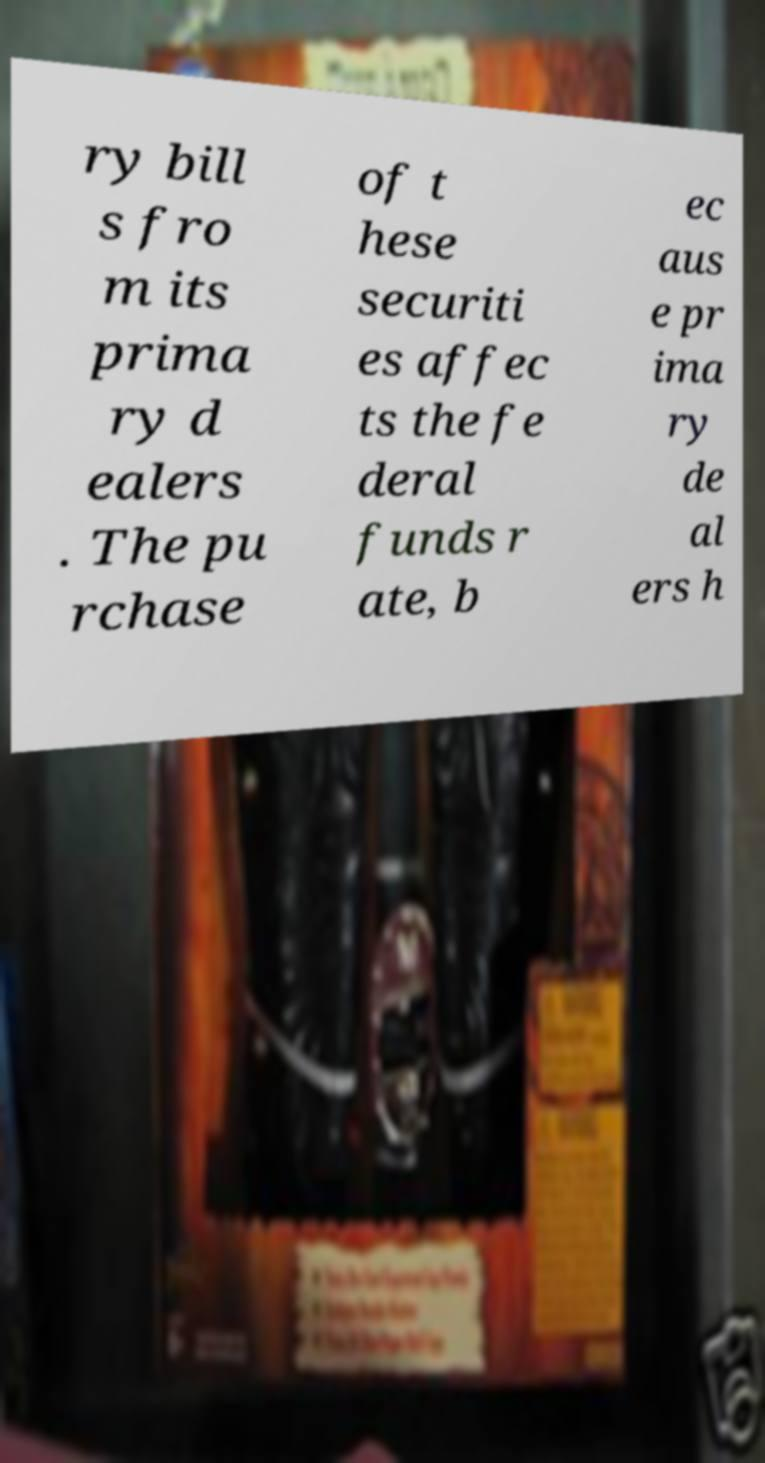Could you assist in decoding the text presented in this image and type it out clearly? ry bill s fro m its prima ry d ealers . The pu rchase of t hese securiti es affec ts the fe deral funds r ate, b ec aus e pr ima ry de al ers h 